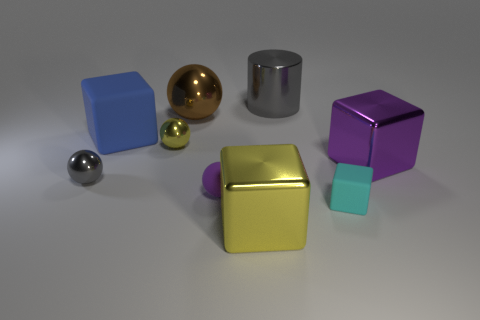Is there any other thing that is the same size as the cyan matte cube?
Provide a short and direct response. Yes. What is the material of the cube that is both in front of the big purple metallic object and on the left side of the small cyan rubber block?
Provide a short and direct response. Metal. Are there fewer big blue matte blocks than yellow metallic things?
Offer a terse response. Yes. There is a rubber block in front of the purple shiny block that is right of the tiny rubber block; how big is it?
Keep it short and to the point. Small. The yellow object that is on the left side of the big block that is in front of the purple thing that is left of the cyan matte block is what shape?
Provide a short and direct response. Sphere. There is a big cylinder that is made of the same material as the brown thing; what is its color?
Offer a terse response. Gray. The big thing to the right of the matte block to the right of the blue matte block that is behind the yellow ball is what color?
Make the answer very short. Purple. How many blocks are either brown things or big purple things?
Ensure brevity in your answer.  1. There is a thing that is the same color as the cylinder; what material is it?
Give a very brief answer. Metal. There is a tiny matte sphere; is its color the same as the large shiny cube that is in front of the tiny purple sphere?
Provide a succinct answer. No. 